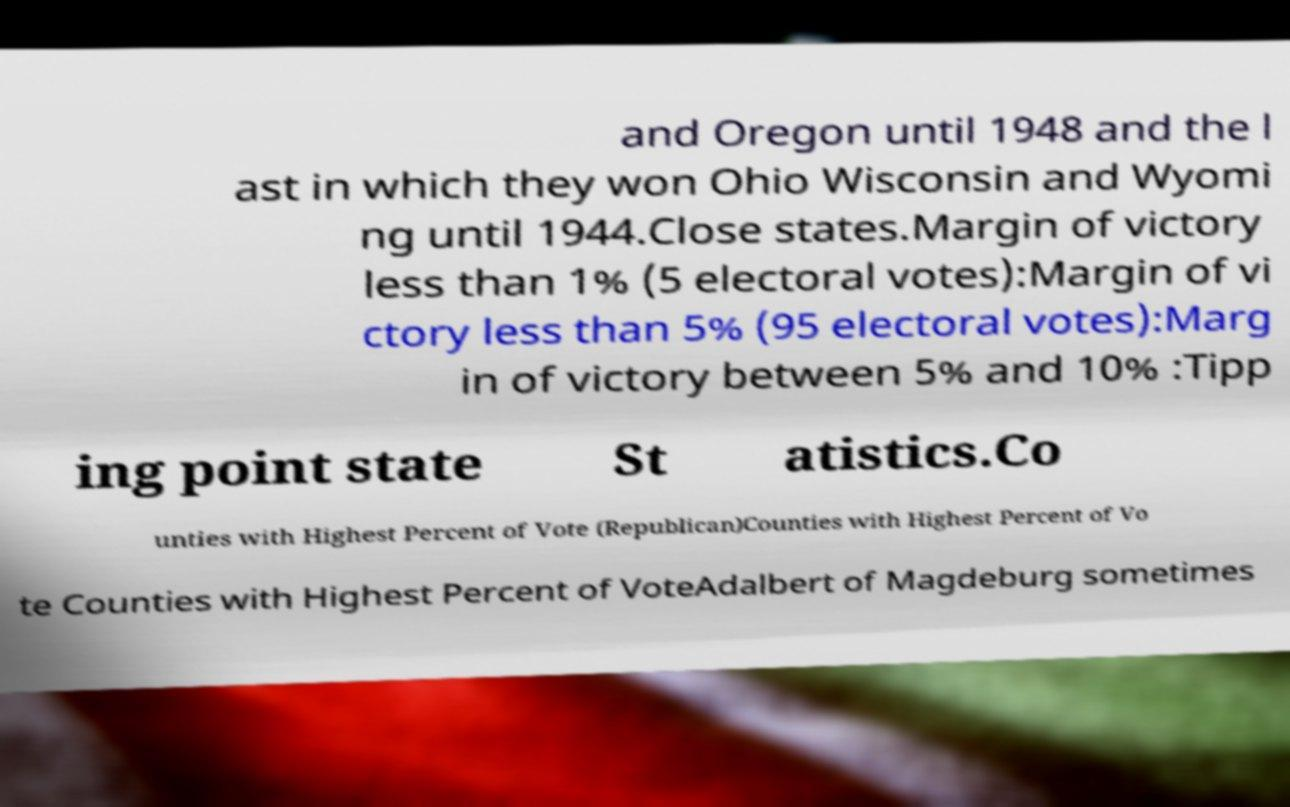Please read and relay the text visible in this image. What does it say? and Oregon until 1948 and the l ast in which they won Ohio Wisconsin and Wyomi ng until 1944.Close states.Margin of victory less than 1% (5 electoral votes):Margin of vi ctory less than 5% (95 electoral votes):Marg in of victory between 5% and 10% :Tipp ing point state St atistics.Co unties with Highest Percent of Vote (Republican)Counties with Highest Percent of Vo te Counties with Highest Percent of VoteAdalbert of Magdeburg sometimes 